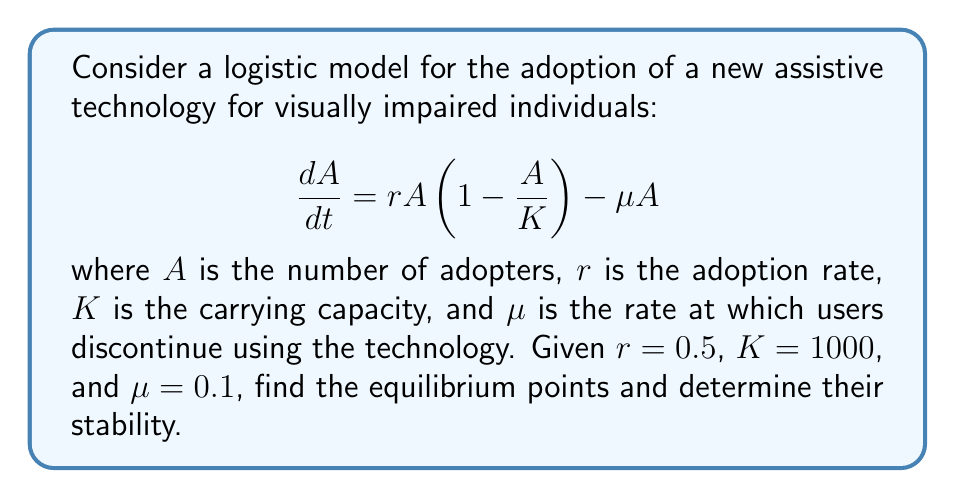Help me with this question. 1) To find the equilibrium points, set $\frac{dA}{dt} = 0$:

   $$0 = rA(1-\frac{A}{K}) - \mu A$$

2) Factor out $A$:

   $$0 = A(r(1-\frac{A}{K}) - \mu)$$

3) Solve for $A$:
   
   a) $A = 0$ is one equilibrium point.
   
   b) For the other point, solve:
      
      $$r(1-\frac{A}{K}) - \mu = 0$$
      $$r - \frac{rA}{K} = \mu$$
      $$r - \mu = \frac{rA}{K}$$
      $$A = \frac{K(r-\mu)}{r}$$

4) Substitute the given values:

   $$A = \frac{1000(0.5-0.1)}{0.5} = 800$$

5) To determine stability, evaluate $\frac{d}{dA}(\frac{dA}{dt})$ at each equilibrium point:

   $$\frac{d}{dA}(\frac{dA}{dt}) = r(1-\frac{2A}{K}) - \mu$$

6) At $A = 0$:
   
   $$\frac{d}{dA}(\frac{dA}{dt}) = r - \mu = 0.5 - 0.1 = 0.4 > 0$$
   
   This is unstable.

7) At $A = 800$:
   
   $$\frac{d}{dA}(\frac{dA}{dt}) = 0.5(1-\frac{2(800)}{1000}) - 0.1 = -0.4 < 0$$
   
   This is stable.
Answer: Equilibrium points: $A=0$ (unstable) and $A=800$ (stable) 